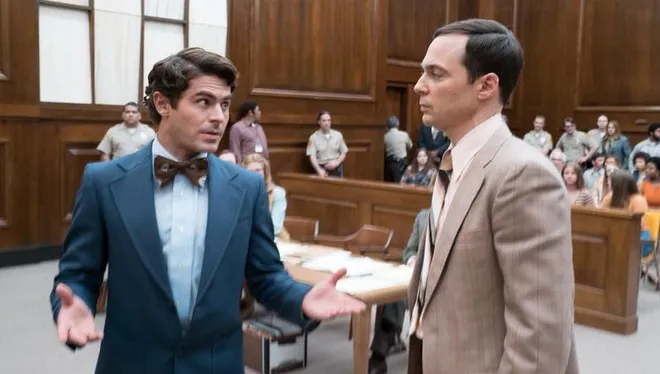Imagine a backstory that could lead to this scene. This courtroom scene could be the pivotal moment in a trial where new, unexpected evidence has been presented, challenging previous narratives and altering the course of the legal outcome. The man in the blue suit might be a passionate lawyer or a key witness making an impassioned plea or delivering a critical testimony, while the man in the beige suit could be his colleague, opponent or client, keenly observing the persuasive argument being put forth. The tension in the room suggests that the stakes are incredibly high, with the man in blue needing to convince the jury or judge of his perspective, and the onlookers are deeply invested in the testimony, aware that the direction of this trial could change imminently. 